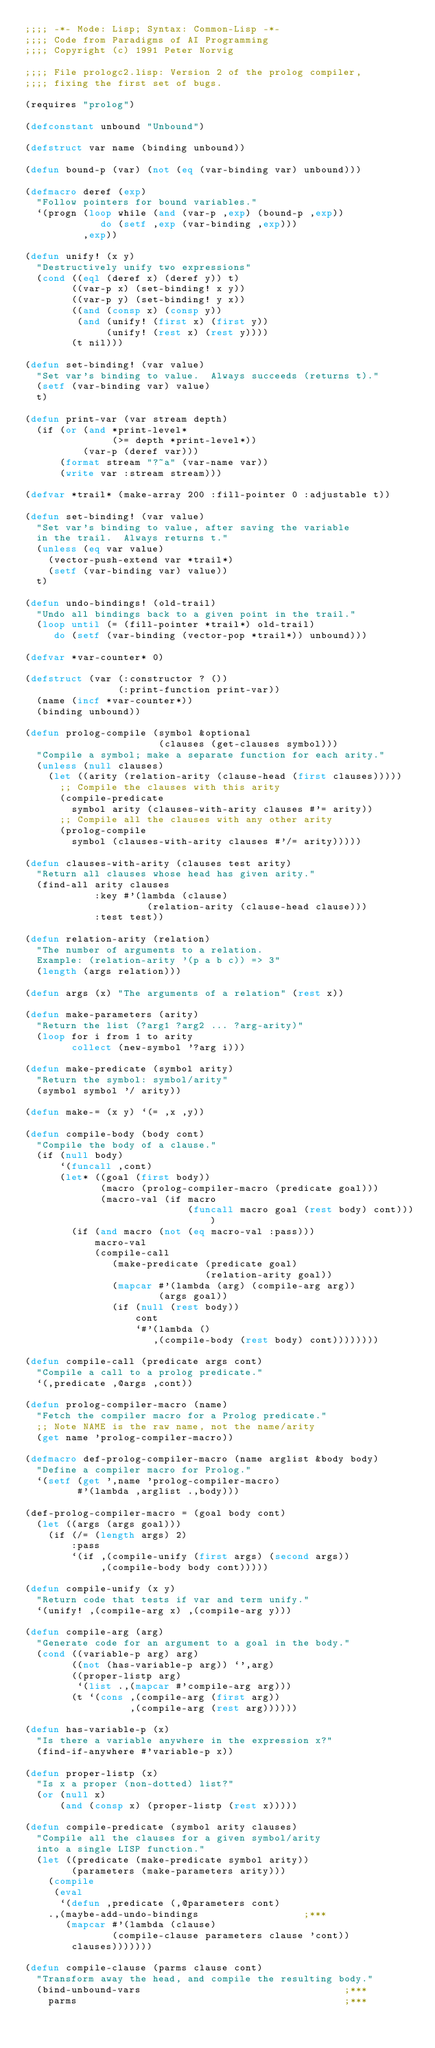Convert code to text. <code><loc_0><loc_0><loc_500><loc_500><_Lisp_>;;;; -*- Mode: Lisp; Syntax: Common-Lisp -*-
;;;; Code from Paradigms of AI Programming
;;;; Copyright (c) 1991 Peter Norvig

;;;; File prologc2.lisp: Version 2 of the prolog compiler,
;;;; fixing the first set of bugs.

(requires "prolog")

(defconstant unbound "Unbound")

(defstruct var name (binding unbound))

(defun bound-p (var) (not (eq (var-binding var) unbound)))

(defmacro deref (exp)
  "Follow pointers for bound variables."
  `(progn (loop while (and (var-p ,exp) (bound-p ,exp))
             do (setf ,exp (var-binding ,exp)))
          ,exp))

(defun unify! (x y)
  "Destructively unify two expressions"
  (cond ((eql (deref x) (deref y)) t)
        ((var-p x) (set-binding! x y))
        ((var-p y) (set-binding! y x))
        ((and (consp x) (consp y))
         (and (unify! (first x) (first y))
              (unify! (rest x) (rest y))))
        (t nil)))

(defun set-binding! (var value)
  "Set var's binding to value.  Always succeeds (returns t)."
  (setf (var-binding var) value)
  t)

(defun print-var (var stream depth)
  (if (or (and *print-level*
               (>= depth *print-level*))
          (var-p (deref var)))
      (format stream "?~a" (var-name var))
      (write var :stream stream)))

(defvar *trail* (make-array 200 :fill-pointer 0 :adjustable t))

(defun set-binding! (var value)
  "Set var's binding to value, after saving the variable
  in the trail.  Always returns t."
  (unless (eq var value)
    (vector-push-extend var *trail*)
    (setf (var-binding var) value))
  t)

(defun undo-bindings! (old-trail)
  "Undo all bindings back to a given point in the trail."
  (loop until (= (fill-pointer *trail*) old-trail)
     do (setf (var-binding (vector-pop *trail*)) unbound)))

(defvar *var-counter* 0)

(defstruct (var (:constructor ? ())
                (:print-function print-var))
  (name (incf *var-counter*))
  (binding unbound))

(defun prolog-compile (symbol &optional
                       (clauses (get-clauses symbol)))
  "Compile a symbol; make a separate function for each arity."
  (unless (null clauses)
    (let ((arity (relation-arity (clause-head (first clauses)))))
      ;; Compile the clauses with this arity
      (compile-predicate
        symbol arity (clauses-with-arity clauses #'= arity))
      ;; Compile all the clauses with any other arity
      (prolog-compile
        symbol (clauses-with-arity clauses #'/= arity)))))

(defun clauses-with-arity (clauses test arity)
  "Return all clauses whose head has given arity."
  (find-all arity clauses
            :key #'(lambda (clause)
                     (relation-arity (clause-head clause)))
            :test test))

(defun relation-arity (relation)
  "The number of arguments to a relation.
  Example: (relation-arity '(p a b c)) => 3"
  (length (args relation)))

(defun args (x) "The arguments of a relation" (rest x))

(defun make-parameters (arity)
  "Return the list (?arg1 ?arg2 ... ?arg-arity)"
  (loop for i from 1 to arity
        collect (new-symbol '?arg i)))

(defun make-predicate (symbol arity)
  "Return the symbol: symbol/arity"
  (symbol symbol '/ arity))

(defun make-= (x y) `(= ,x ,y))

(defun compile-body (body cont)
  "Compile the body of a clause."
  (if (null body)
      `(funcall ,cont)
      (let* ((goal (first body))
             (macro (prolog-compiler-macro (predicate goal)))
             (macro-val (if macro
                            (funcall macro goal (rest body) cont))))
        (if (and macro (not (eq macro-val :pass)))
            macro-val
            (compile-call
               (make-predicate (predicate goal)
                               (relation-arity goal))
               (mapcar #'(lambda (arg) (compile-arg arg))
                       (args goal))
               (if (null (rest body))
                   cont
                   `#'(lambda ()
                      ,(compile-body (rest body) cont))))))))

(defun compile-call (predicate args cont)
  "Compile a call to a prolog predicate."
  `(,predicate ,@args ,cont))

(defun prolog-compiler-macro (name)
  "Fetch the compiler macro for a Prolog predicate."
  ;; Note NAME is the raw name, not the name/arity
  (get name 'prolog-compiler-macro))

(defmacro def-prolog-compiler-macro (name arglist &body body)
  "Define a compiler macro for Prolog."
  `(setf (get ',name 'prolog-compiler-macro)
         #'(lambda ,arglist .,body)))

(def-prolog-compiler-macro = (goal body cont)
  (let ((args (args goal)))
    (if (/= (length args) 2)
        :pass
        `(if ,(compile-unify (first args) (second args))
             ,(compile-body body cont)))))

(defun compile-unify (x y)
  "Return code that tests if var and term unify."
  `(unify! ,(compile-arg x) ,(compile-arg y)))

(defun compile-arg (arg)
  "Generate code for an argument to a goal in the body."
  (cond ((variable-p arg) arg)
        ((not (has-variable-p arg)) `',arg)
        ((proper-listp arg)
         `(list .,(mapcar #'compile-arg arg)))
        (t `(cons ,(compile-arg (first arg))
                  ,(compile-arg (rest arg))))))

(defun has-variable-p (x)
  "Is there a variable anywhere in the expression x?"
  (find-if-anywhere #'variable-p x))

(defun proper-listp (x)
  "Is x a proper (non-dotted) list?"
  (or (null x)
      (and (consp x) (proper-listp (rest x)))))

(defun compile-predicate (symbol arity clauses)
  "Compile all the clauses for a given symbol/arity
  into a single LISP function."
  (let ((predicate (make-predicate symbol arity))
        (parameters (make-parameters arity)))
    (compile
     (eval
      `(defun ,predicate (,@parameters cont)
	.,(maybe-add-undo-bindings                  ;***
	   (mapcar #'(lambda (clause)
		       (compile-clause parameters clause 'cont))
	    clauses)))))))

(defun compile-clause (parms clause cont)
  "Transform away the head, and compile the resulting body."
  (bind-unbound-vars                                   ;***
    parms                                              ;***</code> 